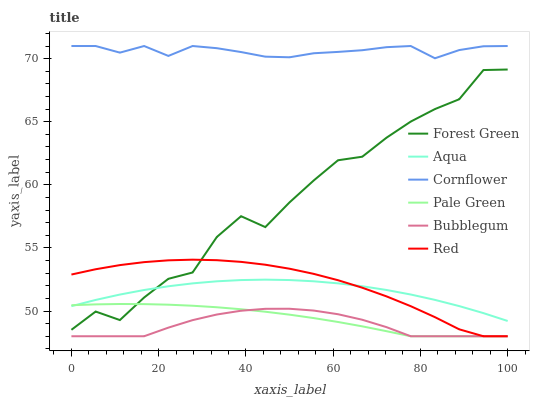Does Aqua have the minimum area under the curve?
Answer yes or no. No. Does Aqua have the maximum area under the curve?
Answer yes or no. No. Is Aqua the smoothest?
Answer yes or no. No. Is Aqua the roughest?
Answer yes or no. No. Does Aqua have the lowest value?
Answer yes or no. No. Does Aqua have the highest value?
Answer yes or no. No. Is Bubblegum less than Forest Green?
Answer yes or no. Yes. Is Cornflower greater than Red?
Answer yes or no. Yes. Does Bubblegum intersect Forest Green?
Answer yes or no. No. 